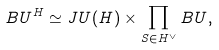Convert formula to latex. <formula><loc_0><loc_0><loc_500><loc_500>B U ^ { H } \simeq J U ( H ) \times \prod _ { S \in H ^ { \vee } } B U ,</formula> 